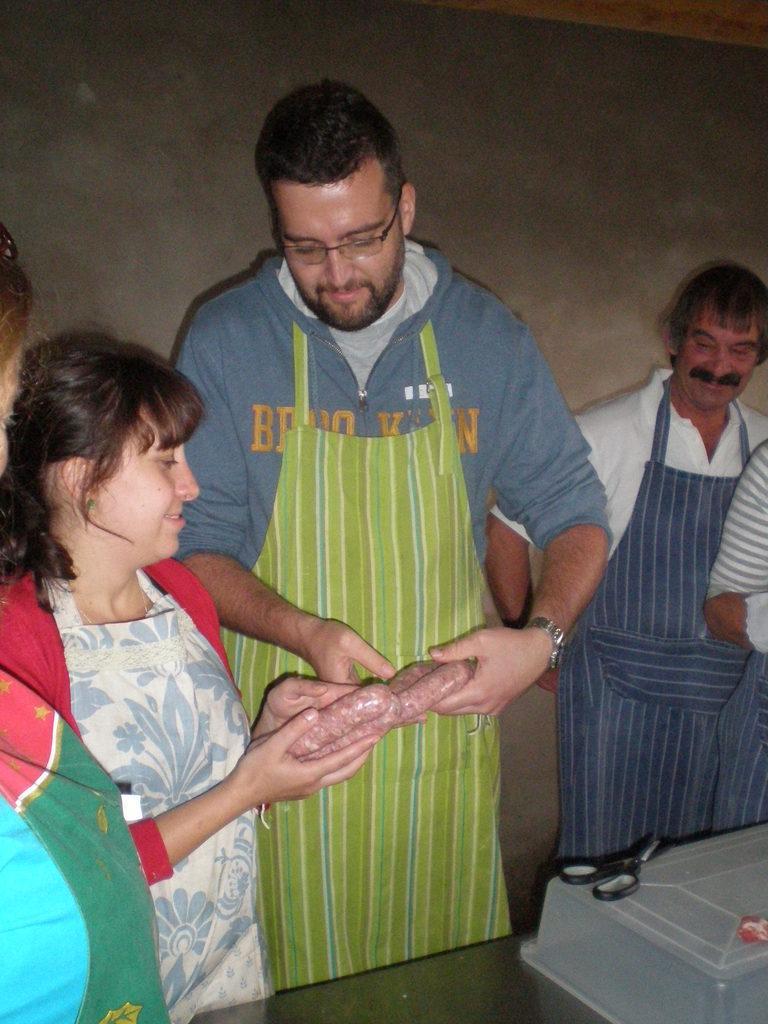Can you describe this image briefly? In this picture I can see group of people standing, there are two persons holding an item, there is a plastic container and scissors on the table, and in the background there is a wall. 